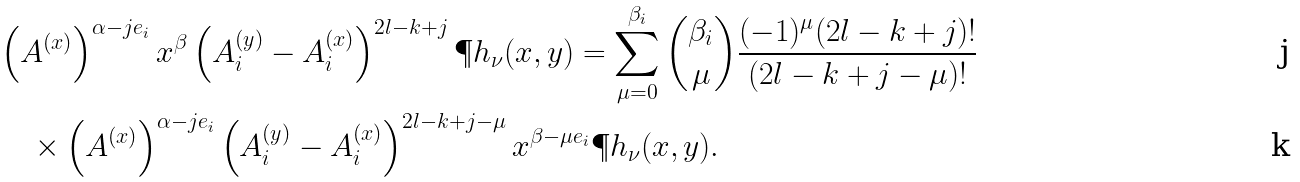Convert formula to latex. <formula><loc_0><loc_0><loc_500><loc_500>& \left ( A ^ { ( x ) } \right ) ^ { \alpha - j e _ { i } } x ^ { \beta } \left ( A _ { i } ^ { ( y ) } - A _ { i } ^ { ( x ) } \right ) ^ { 2 l - k + j } \P h _ { \nu } ( x , y ) = \sum _ { \mu = 0 } ^ { \beta _ { i } } \binom { \beta _ { i } } { \mu } \frac { ( - 1 ) ^ { \mu } ( 2 l - k + j ) ! } { ( 2 l - k + j - \mu ) ! } \\ & \quad \times \left ( A ^ { ( x ) } \right ) ^ { \alpha - j e _ { i } } \left ( A _ { i } ^ { ( y ) } - A _ { i } ^ { ( x ) } \right ) ^ { 2 l - k + j - \mu } x ^ { \beta - \mu e _ { i } } \P h _ { \nu } ( x , y ) .</formula> 